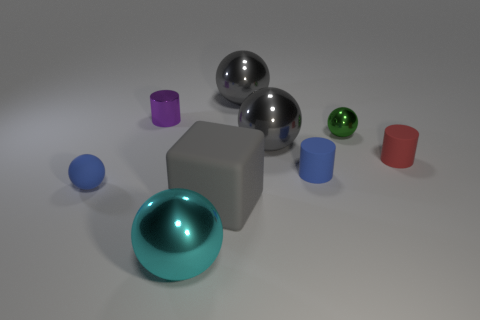If you were to describe the mood of this scene, what would you say? The mood of the scene is clean, orderly, and contemplative. The neutral background and the simplistic shapes of the objects contribute to a minimalistic and tranquil vibe, evoking a sense of calm and balance. 